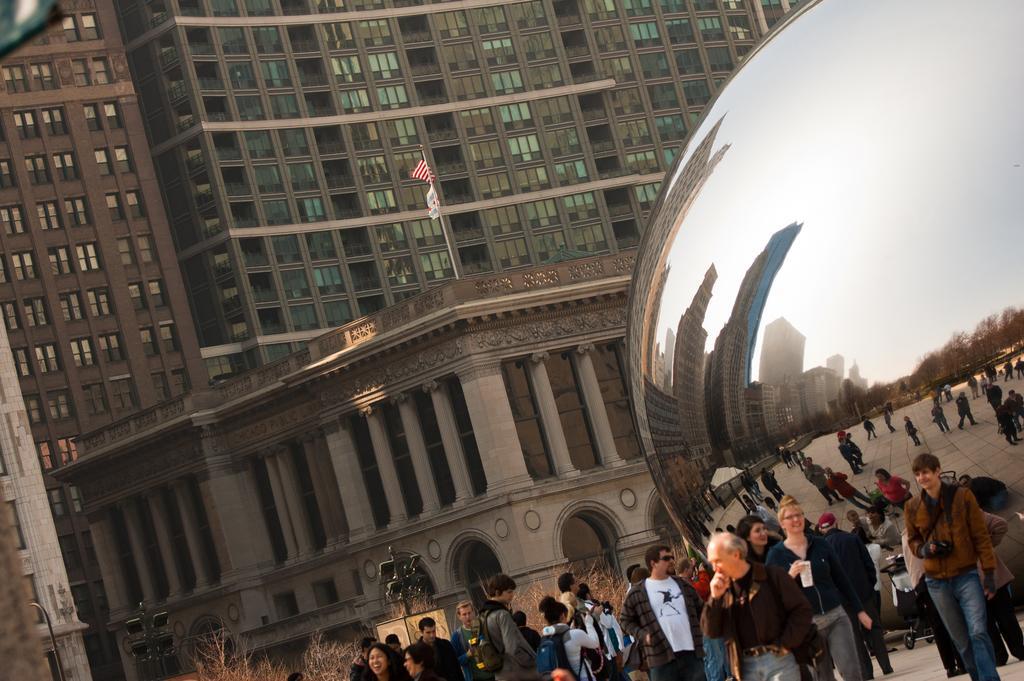Could you give a brief overview of what you see in this image? In this image there is a building, there is a building truncated towards the left of the image, there is a pole on the building, there are flags, there are pillars, there are plants, there are groups of persons, there is an object truncated towards the right of the image, there are lights, there are persons holding an object, there is an object truncated towards the top of the image. 